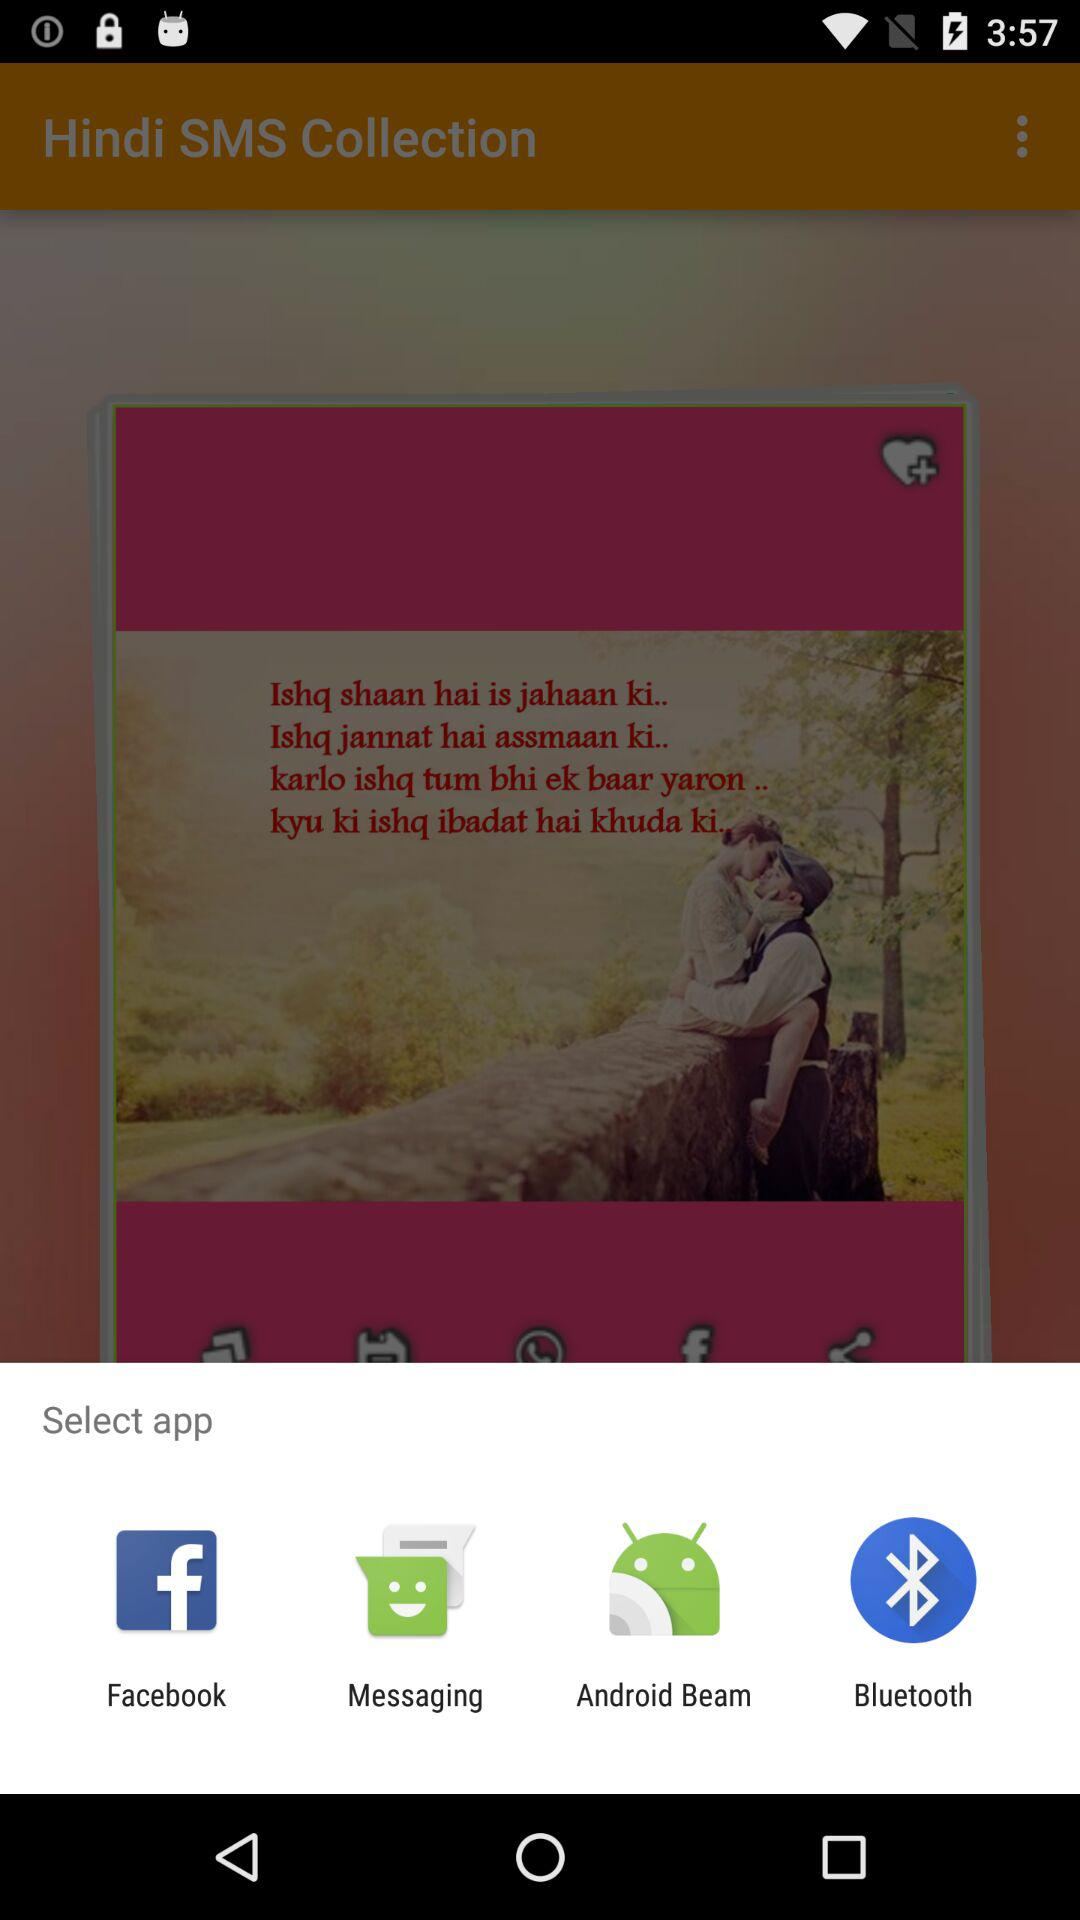How many apps are available in the share menu?
Answer the question using a single word or phrase. 4 